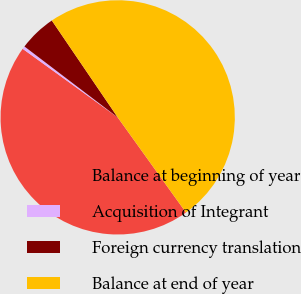Convert chart. <chart><loc_0><loc_0><loc_500><loc_500><pie_chart><fcel>Balance at beginning of year<fcel>Acquisition of Integrant<fcel>Foreign currency translation<fcel>Balance at end of year<nl><fcel>44.85%<fcel>0.4%<fcel>5.15%<fcel>49.6%<nl></chart> 